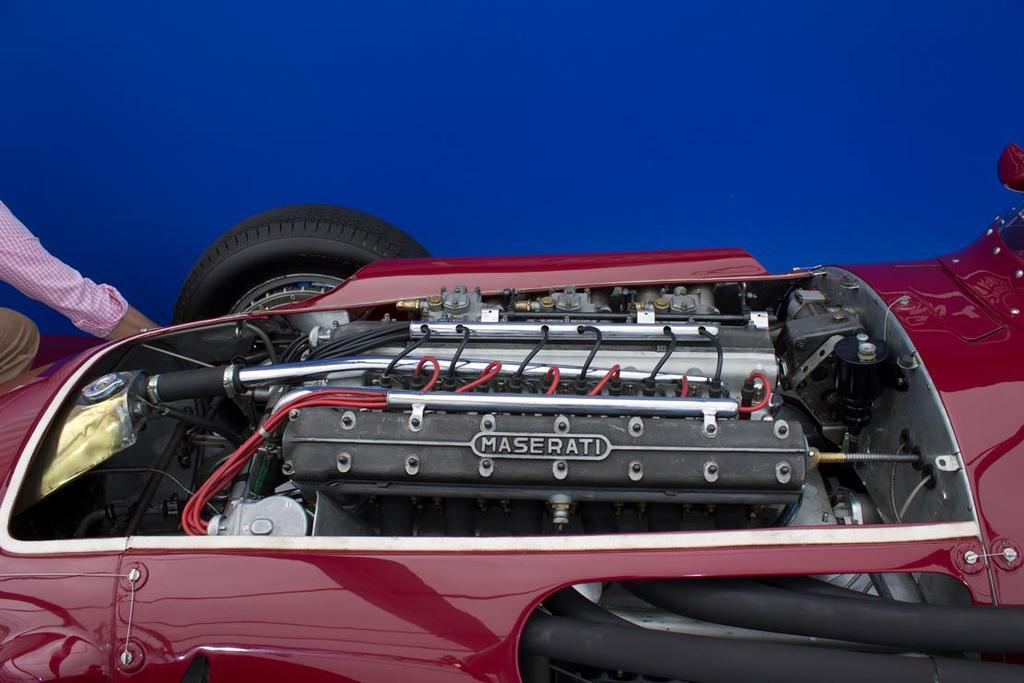What is the main subject of the image? The main subject of the image is an engine of a car. What other parts of a car can be seen in the image? There are wheels with tires in the image. Are there any people present in the image? Yes, there is a person present on the left side of the image. What is the condition of the meeting in the image? There is no meeting present in the image, so it is not possible to determine its condition. 